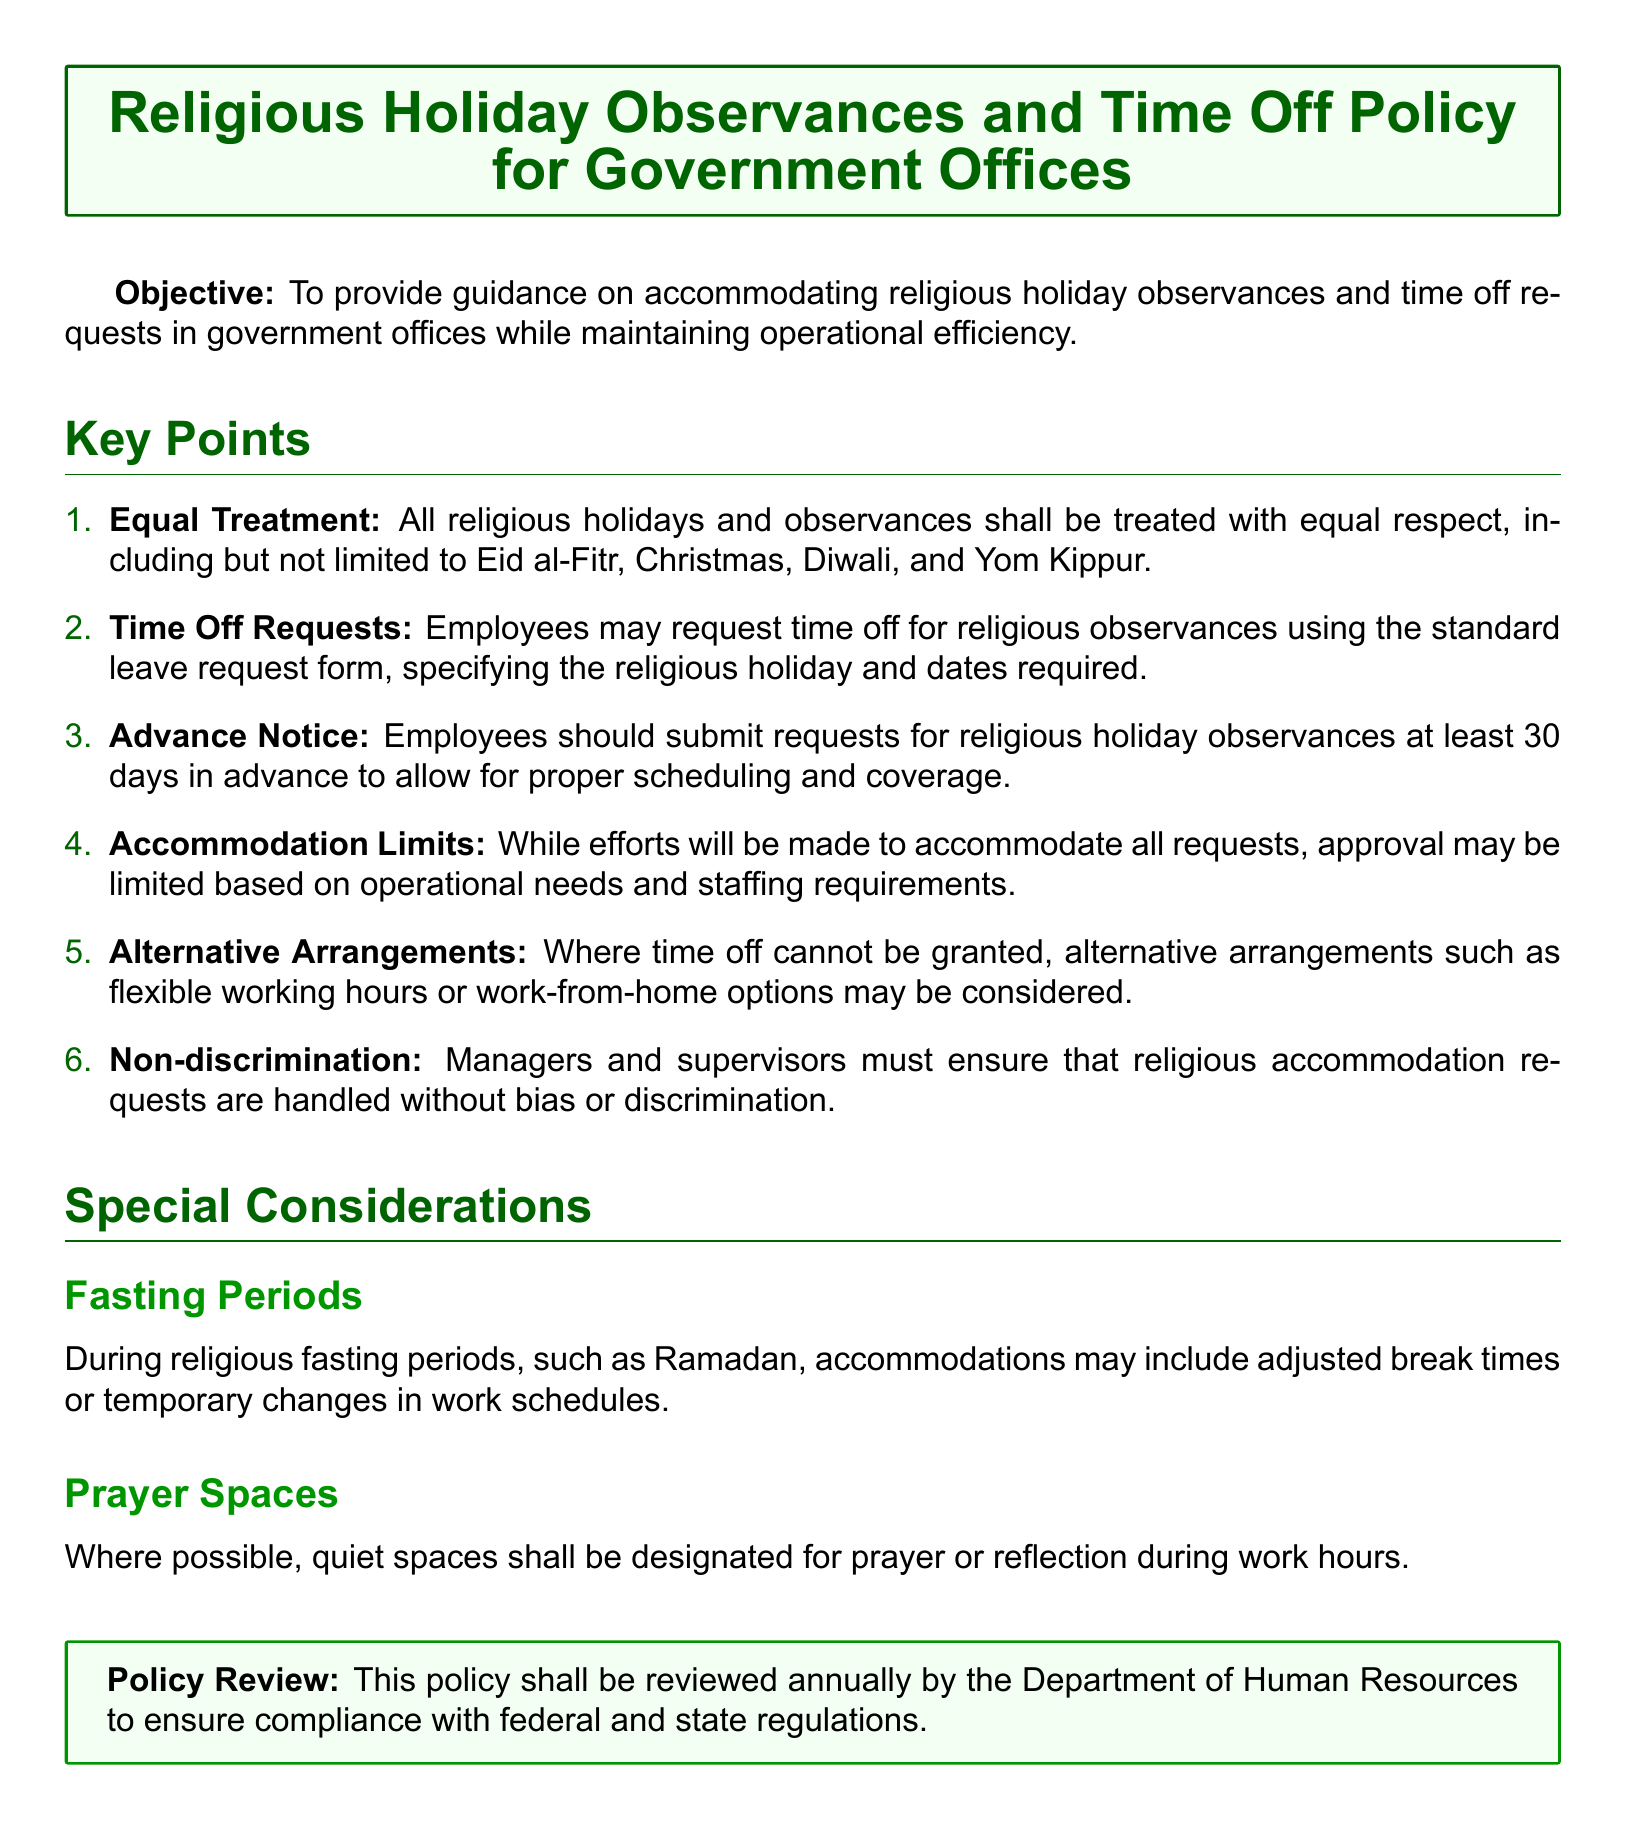What is the objective of the policy? The objective is to provide guidance on accommodating religious holiday observances and time off requests in government offices while maintaining operational efficiency.
Answer: To provide guidance on accommodating religious holiday observances and time off requests in government offices while maintaining operational efficiency How many days in advance should leave requests be submitted? The document specifies the required notice period for submitting leave requests.
Answer: 30 days What is the main focus of the first key point? The first key point emphasizes the equal treatment of all religious holidays and observances.
Answer: Equal Treatment What accommodations may be made during fasting periods? The document outlines specific accommodations during religious fasting periods.
Answer: Adjusted break times What must managers ensure when handling accommodation requests? This aspect of the document deals with the importance of fairness in handling requests.
Answer: Non-discrimination 